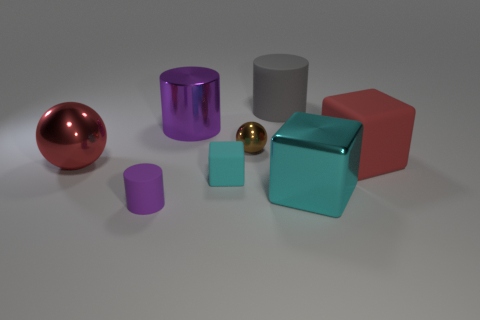What material is the small brown object?
Keep it short and to the point. Metal. The large cyan shiny object to the left of the red block has what shape?
Provide a short and direct response. Cube. The metal sphere that is the same size as the cyan rubber object is what color?
Your answer should be very brief. Brown. Is the material of the purple cylinder behind the large cyan shiny object the same as the big red block?
Provide a short and direct response. No. There is a rubber thing that is both right of the tiny purple rubber cylinder and left of the gray rubber cylinder; what is its size?
Offer a terse response. Small. There is a purple cylinder that is in front of the large metal cube; what size is it?
Your answer should be very brief. Small. There is a large object that is the same color as the big shiny sphere; what is its shape?
Provide a succinct answer. Cube. The red thing that is in front of the red object right of the small rubber thing on the left side of the cyan rubber block is what shape?
Ensure brevity in your answer.  Sphere. What number of other objects are the same shape as the small cyan rubber object?
Your answer should be very brief. 2. What number of shiny objects are either tiny blue cubes or big purple cylinders?
Keep it short and to the point. 1. 